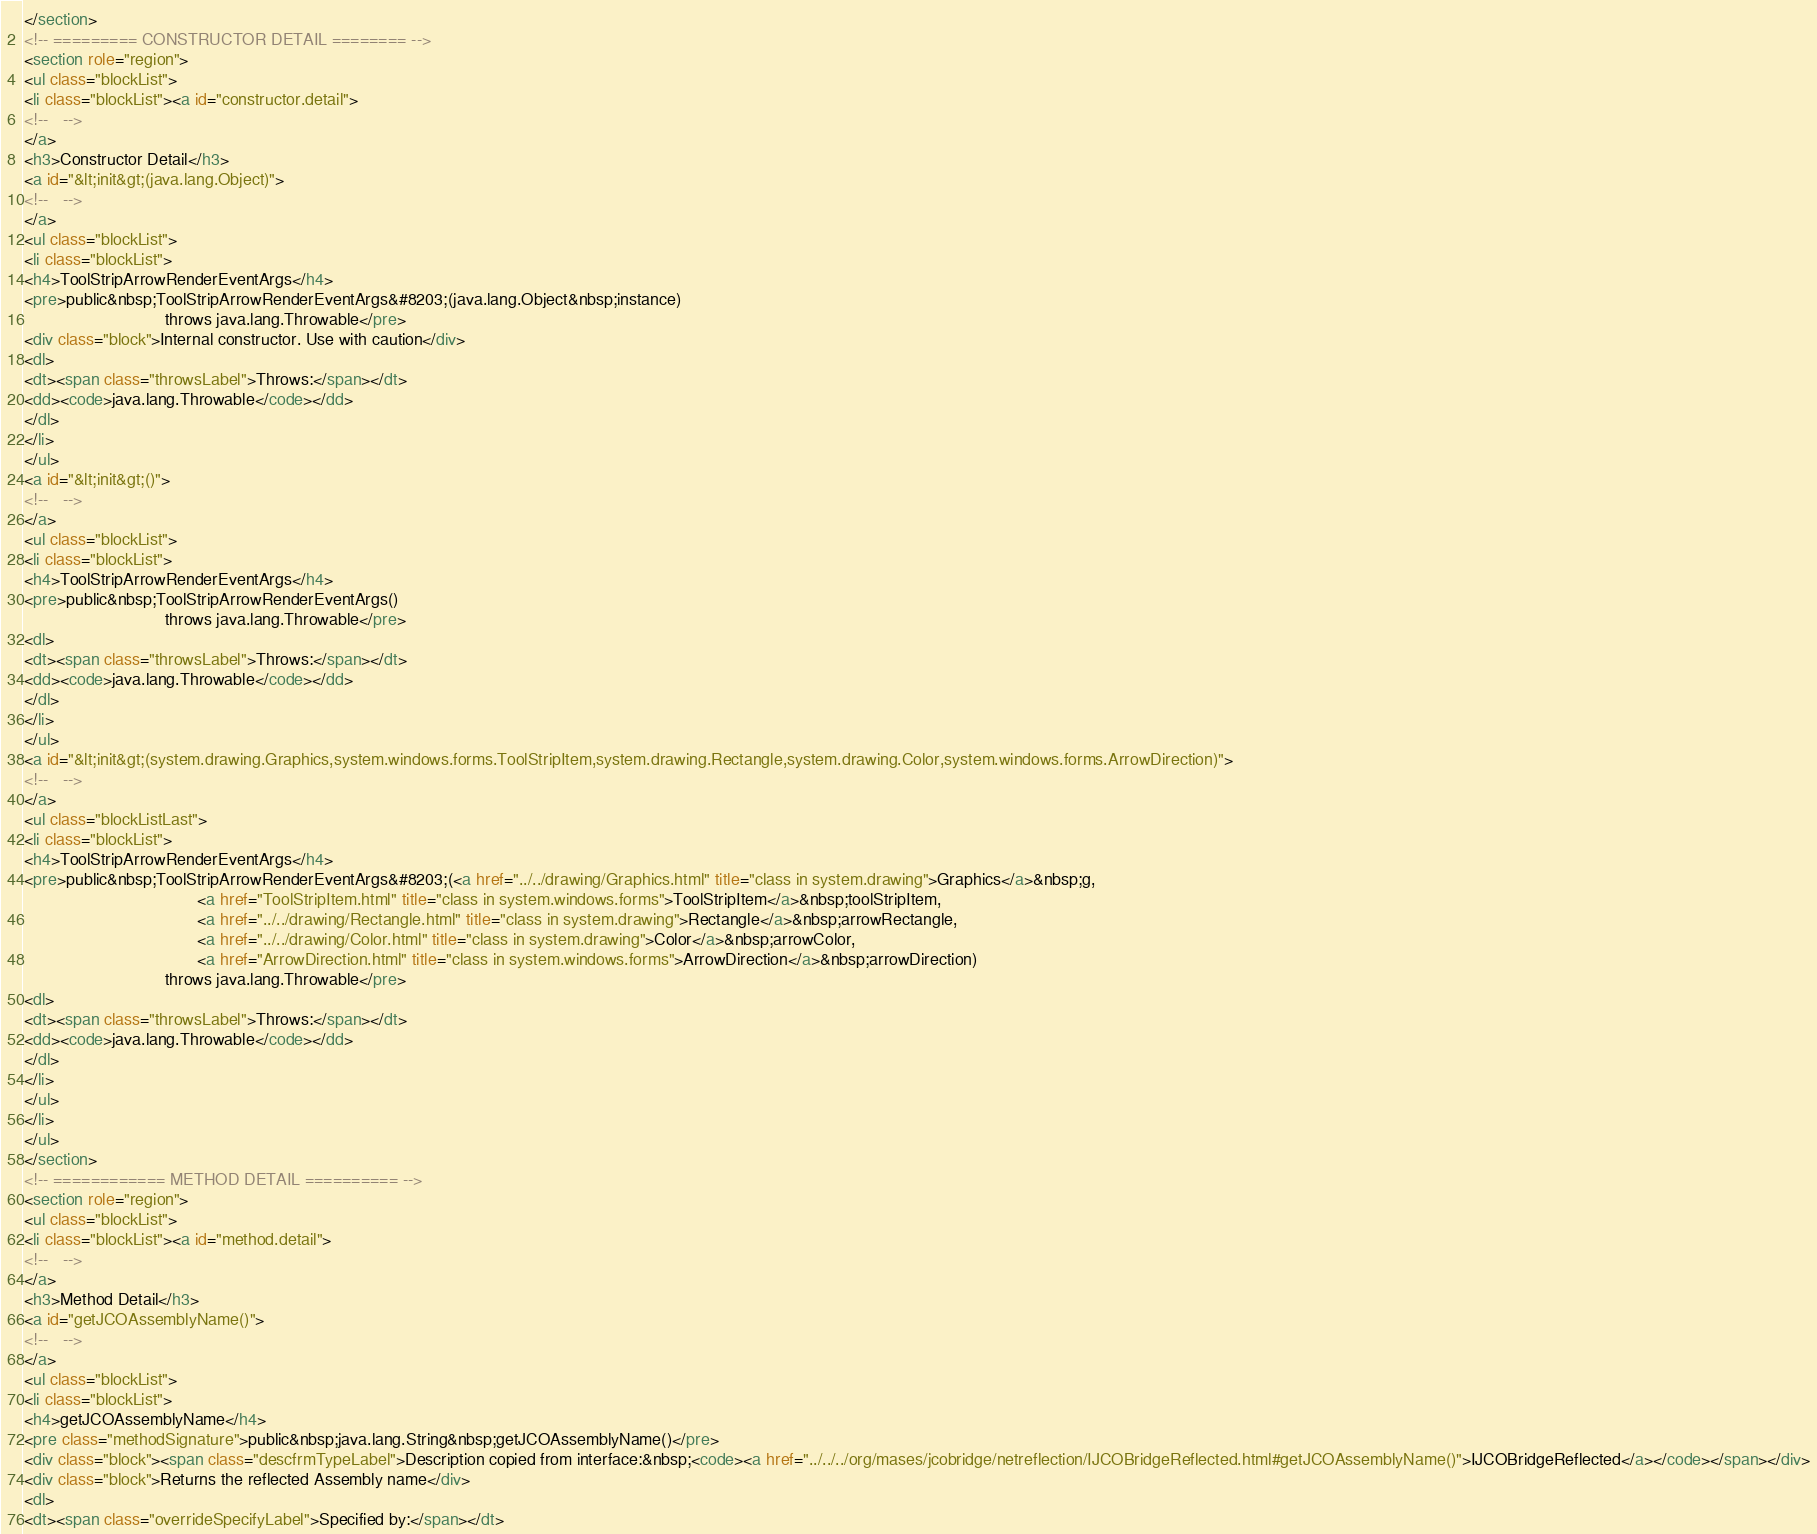Convert code to text. <code><loc_0><loc_0><loc_500><loc_500><_HTML_></section>
<!-- ========= CONSTRUCTOR DETAIL ======== -->
<section role="region">
<ul class="blockList">
<li class="blockList"><a id="constructor.detail">
<!--   -->
</a>
<h3>Constructor Detail</h3>
<a id="&lt;init&gt;(java.lang.Object)">
<!--   -->
</a>
<ul class="blockList">
<li class="blockList">
<h4>ToolStripArrowRenderEventArgs</h4>
<pre>public&nbsp;ToolStripArrowRenderEventArgs&#8203;(java.lang.Object&nbsp;instance)
                              throws java.lang.Throwable</pre>
<div class="block">Internal constructor. Use with caution</div>
<dl>
<dt><span class="throwsLabel">Throws:</span></dt>
<dd><code>java.lang.Throwable</code></dd>
</dl>
</li>
</ul>
<a id="&lt;init&gt;()">
<!--   -->
</a>
<ul class="blockList">
<li class="blockList">
<h4>ToolStripArrowRenderEventArgs</h4>
<pre>public&nbsp;ToolStripArrowRenderEventArgs()
                              throws java.lang.Throwable</pre>
<dl>
<dt><span class="throwsLabel">Throws:</span></dt>
<dd><code>java.lang.Throwable</code></dd>
</dl>
</li>
</ul>
<a id="&lt;init&gt;(system.drawing.Graphics,system.windows.forms.ToolStripItem,system.drawing.Rectangle,system.drawing.Color,system.windows.forms.ArrowDirection)">
<!--   -->
</a>
<ul class="blockListLast">
<li class="blockList">
<h4>ToolStripArrowRenderEventArgs</h4>
<pre>public&nbsp;ToolStripArrowRenderEventArgs&#8203;(<a href="../../drawing/Graphics.html" title="class in system.drawing">Graphics</a>&nbsp;g,
                                     <a href="ToolStripItem.html" title="class in system.windows.forms">ToolStripItem</a>&nbsp;toolStripItem,
                                     <a href="../../drawing/Rectangle.html" title="class in system.drawing">Rectangle</a>&nbsp;arrowRectangle,
                                     <a href="../../drawing/Color.html" title="class in system.drawing">Color</a>&nbsp;arrowColor,
                                     <a href="ArrowDirection.html" title="class in system.windows.forms">ArrowDirection</a>&nbsp;arrowDirection)
                              throws java.lang.Throwable</pre>
<dl>
<dt><span class="throwsLabel">Throws:</span></dt>
<dd><code>java.lang.Throwable</code></dd>
</dl>
</li>
</ul>
</li>
</ul>
</section>
<!-- ============ METHOD DETAIL ========== -->
<section role="region">
<ul class="blockList">
<li class="blockList"><a id="method.detail">
<!--   -->
</a>
<h3>Method Detail</h3>
<a id="getJCOAssemblyName()">
<!--   -->
</a>
<ul class="blockList">
<li class="blockList">
<h4>getJCOAssemblyName</h4>
<pre class="methodSignature">public&nbsp;java.lang.String&nbsp;getJCOAssemblyName()</pre>
<div class="block"><span class="descfrmTypeLabel">Description copied from interface:&nbsp;<code><a href="../../../org/mases/jcobridge/netreflection/IJCOBridgeReflected.html#getJCOAssemblyName()">IJCOBridgeReflected</a></code></span></div>
<div class="block">Returns the reflected Assembly name</div>
<dl>
<dt><span class="overrideSpecifyLabel">Specified by:</span></dt></code> 